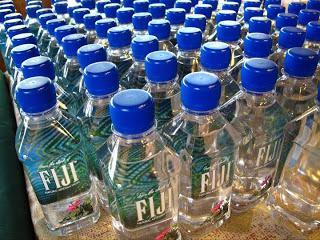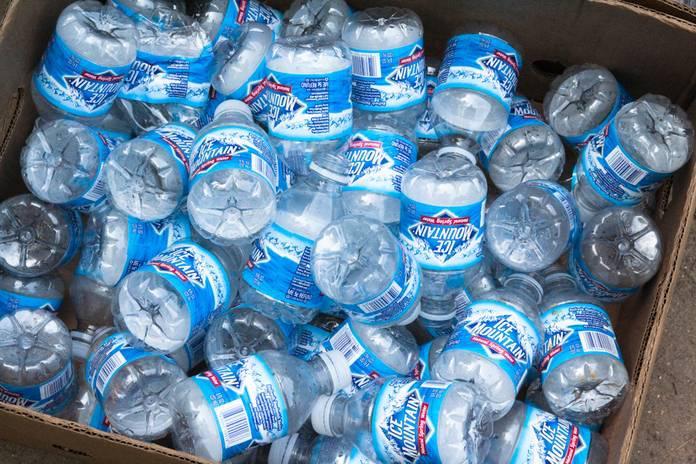The first image is the image on the left, the second image is the image on the right. For the images displayed, is the sentence "All bottles of water have blue plastic caps." factually correct? Answer yes or no. No. 